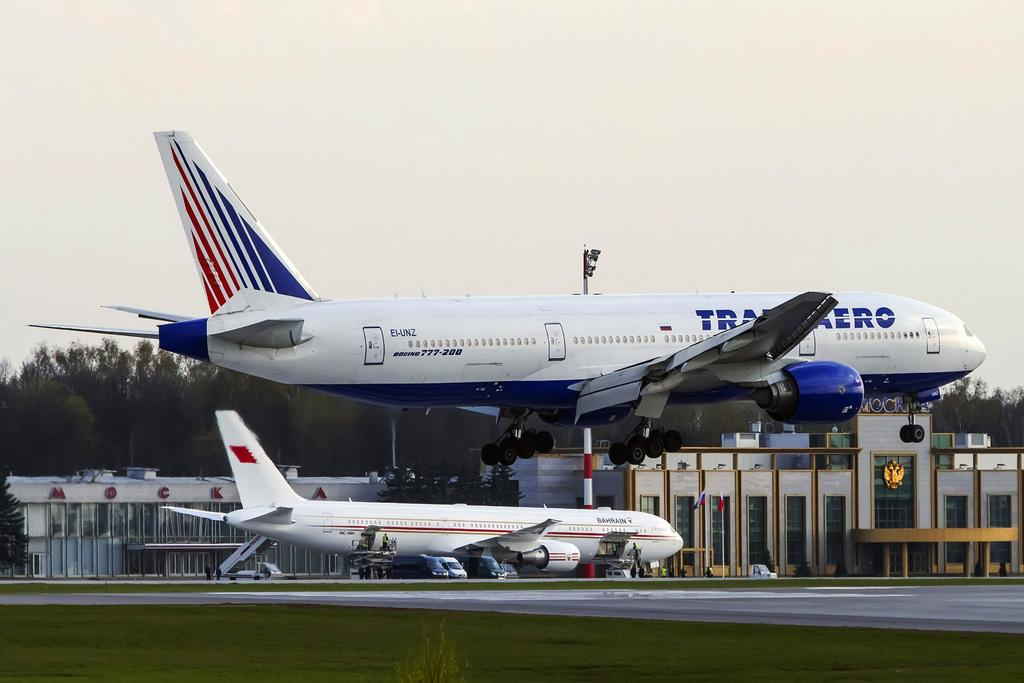<image>
Provide a brief description of the given image. EI-UNZ sign and Boeing 777-200 sign on a airplane. 